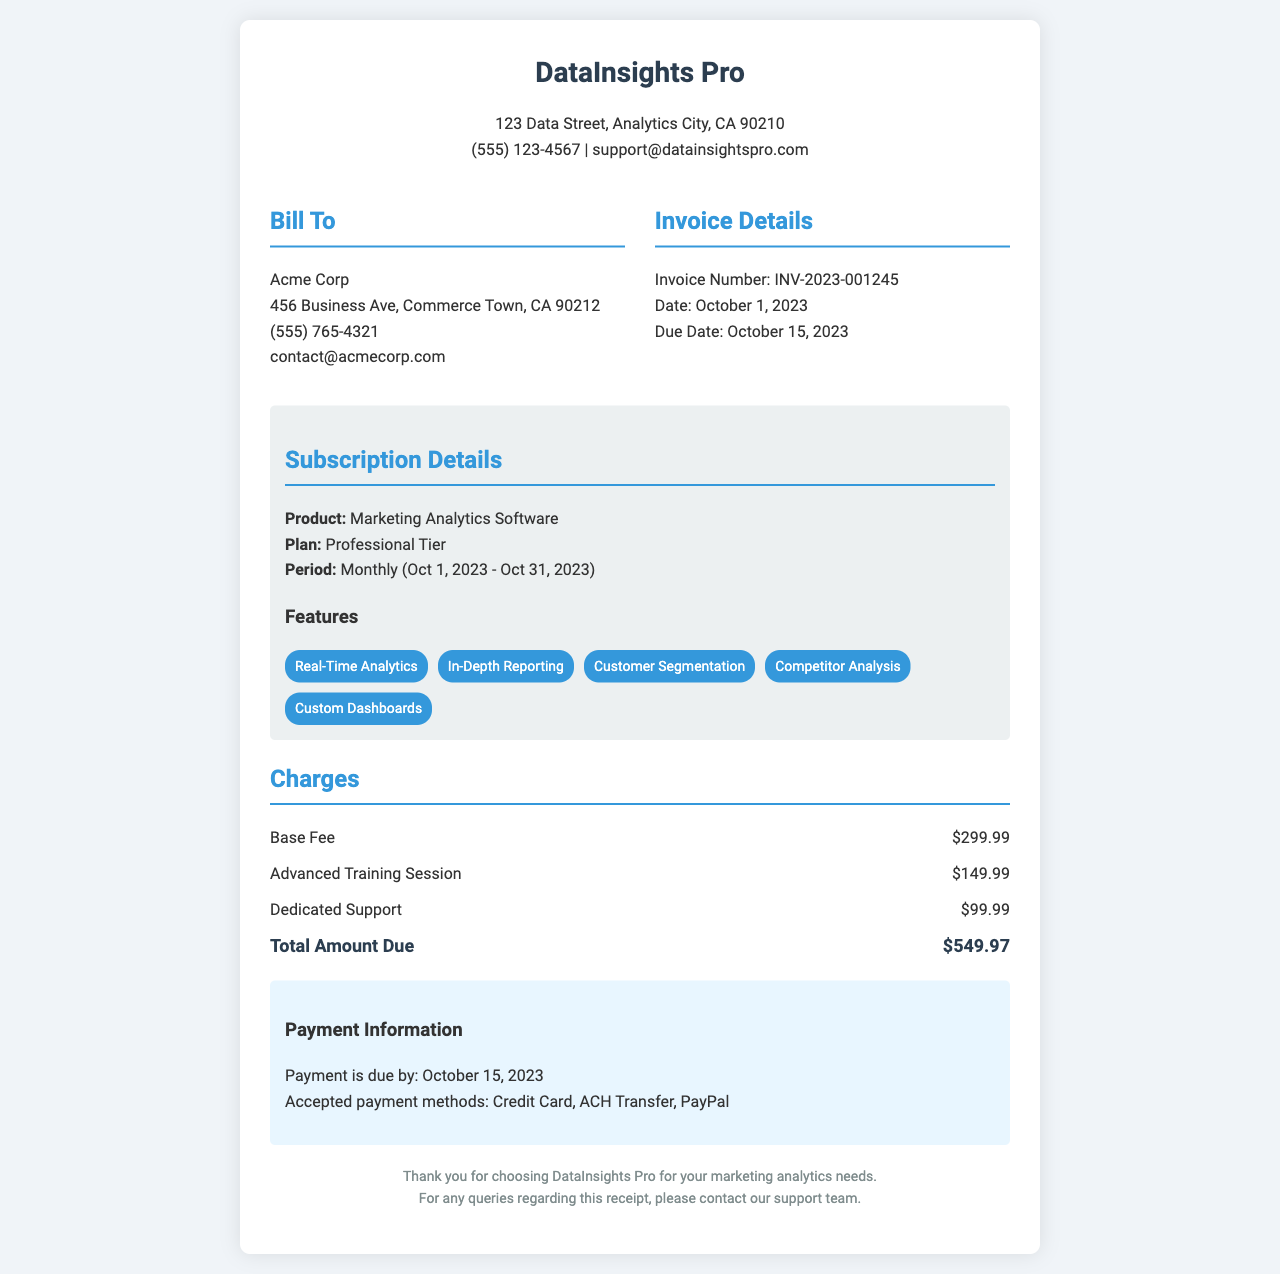What is the name of the software? The document specifies that the software is called Marketing Analytics Software.
Answer: Marketing Analytics Software What is the invoice number? The document provides the invoice number as INV-2023-001245.
Answer: INV-2023-001245 What is the total amount due? The total amount due is clearly stated in the document as $549.97.
Answer: $549.97 What is the base fee charge? The document lists the base fee charge explicitly as $299.99.
Answer: $299.99 When is the payment due? The document indicates that the payment is due by October 15, 2023.
Answer: October 15, 2023 What company issued this receipt? The company issuing the receipt is DataInsights Pro, as shown in the header.
Answer: DataInsights Pro What feature involves analyzing competitors? The feature that involves analyzing competitors is called Competitor Analysis.
Answer: Competitor Analysis How many features are listed in the receipt? There are five features listed in the subscription details section of the document.
Answer: Five What is the period of the subscription? The subscription period is stated as Monthly (Oct 1, 2023 - Oct 31, 2023).
Answer: Monthly (Oct 1, 2023 - Oct 31, 2023) 